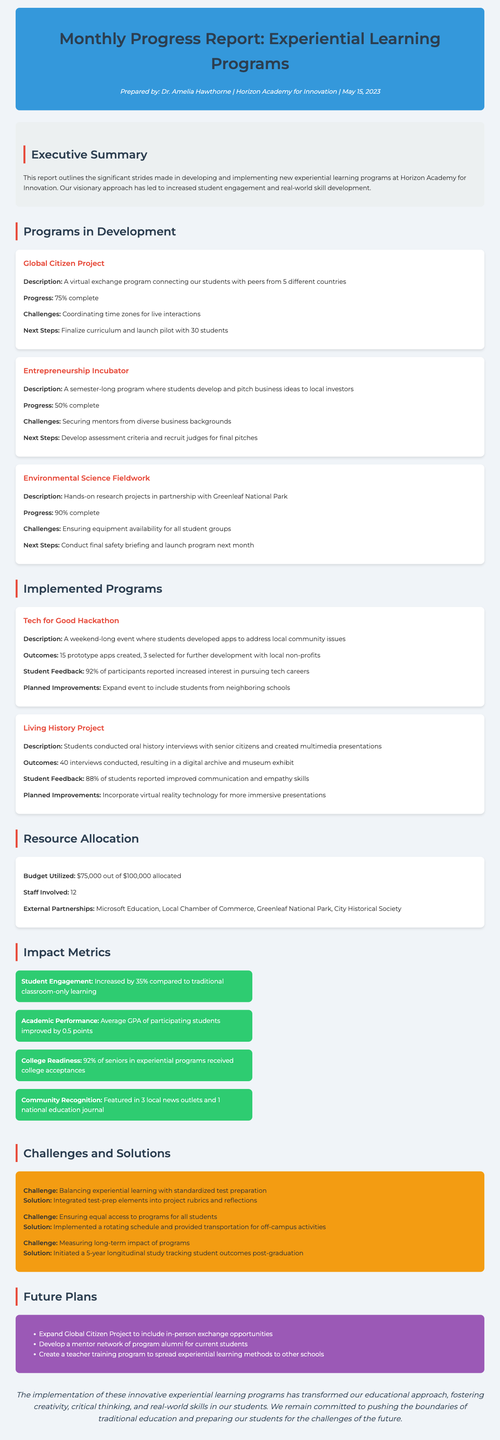What is the report title? The report title is stated at the beginning of the document.
Answer: Monthly Progress Report: Experiential Learning Programs Who prepared the report? The teacher who prepared the report is mentioned in the meta info section.
Answer: Dr. Amelia Hawthorne What is the completion percentage of the Environmental Science Fieldwork program? The completion percentage is specified in the programs in development section.
Answer: 90% complete How many external partnerships are listed in the resource allocation section? The number of external partnerships can be counted from the list provided.
Answer: 4 What were the outcomes of the Tech for Good Hackathon? The outcomes are outlined in the implemented programs section.
Answer: 15 prototype apps created, 3 selected for further development with local non-profits What challenge is associated with ensuring equal access to programs for all students? The challenge is specifically stated in the challenges and solutions section.
Answer: Ensuring equal access to programs for all students What is the average GPA improvement for participating students? This metric is provided in the impact metrics section.
Answer: 0.5 points What future plan involves creating a teacher training program? The specific future plan is outlined clearly in the future plans section.
Answer: Create a teacher training program to spread experiential learning methods to other schools What percentage of seniors in experiential programs received college acceptances? This percentage is directly listed in the impact metrics.
Answer: 92% 